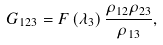<formula> <loc_0><loc_0><loc_500><loc_500>G _ { 1 2 3 } = F \left ( \lambda _ { 3 } \right ) \frac { \rho _ { 1 2 } \rho _ { 2 3 } } { \rho _ { 1 3 } } ,</formula> 